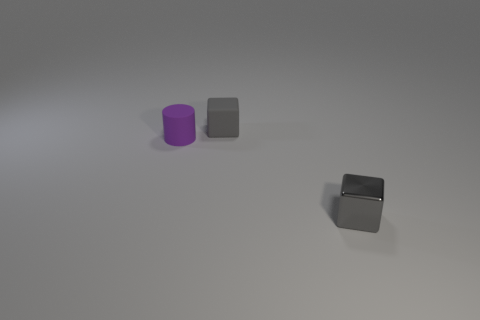Add 2 large brown metal cubes. How many objects exist? 5 Subtract all cubes. How many objects are left? 1 Subtract all big red metallic objects. Subtract all small gray matte things. How many objects are left? 2 Add 1 purple cylinders. How many purple cylinders are left? 2 Add 2 tiny gray shiny things. How many tiny gray shiny things exist? 3 Subtract 0 blue cylinders. How many objects are left? 3 